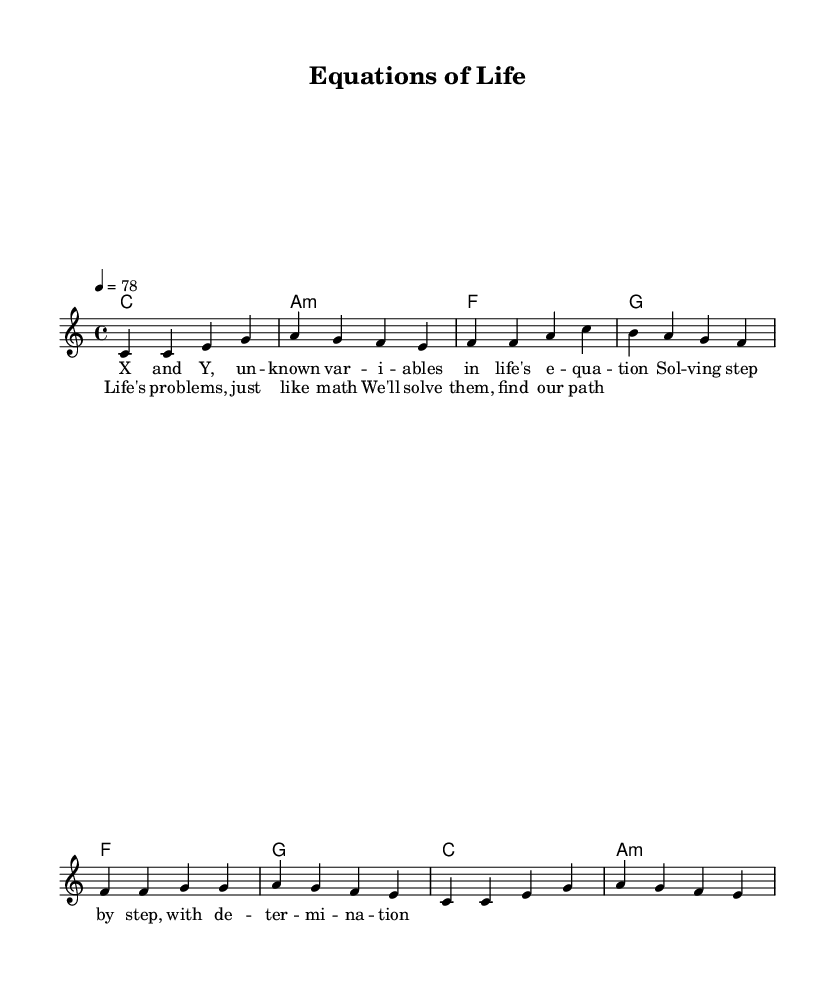What is the key signature of this music? The key signature is C major, which indicates there are no sharps or flats present in the music.
Answer: C major What is the time signature of this piece? The time signature is 4/4, which means there are four beats per measure and a quarter note receives one beat.
Answer: 4/4 What is the tempo marking given in the music? The tempo marking indicates a speed of 78 beats per minute, setting the pace for how the music should be played.
Answer: 78 How many measures are there in the verse? The verse consists of four measures, as indicated by the grouping of notes in the section labeled as "Verse."
Answer: 4 What tonal harmony is present during the chorus? The tonal harmony for the chorus shifts from F major to G major, and then resolves to C major before returning to A minor.
Answer: F to G to C to A minor What lyrical themes are present in this reggae piece? The lyrics draw parallels between problem-solving in mathematics and overcoming challenges in life, emphasizing determination and finding solutions one step at a time.
Answer: Problem-solving and determination What style of music is this piece categorized under? This piece is categorized as reggae music, evident by its rhythmic structure and laid-back groove indicated in the melody and harmonies.
Answer: Reggae 